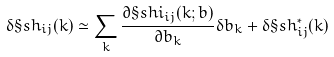Convert formula to latex. <formula><loc_0><loc_0><loc_500><loc_500>\delta \S s h _ { i j } ( k ) \simeq \sum _ { k } \frac { \partial \S s h i _ { i j } ( k ; b ) } { \partial b _ { k } } \delta b _ { k } + \delta \S s h _ { i j } ^ { * } ( k )</formula> 